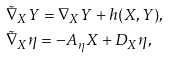<formula> <loc_0><loc_0><loc_500><loc_500>& \tilde { \nabla } _ { X } Y = \nabla _ { X } Y + h ( X , Y ) , \, \\ & \tilde { \nabla } _ { X } \eta = - A _ { \eta } X + D _ { X } \eta ,</formula> 